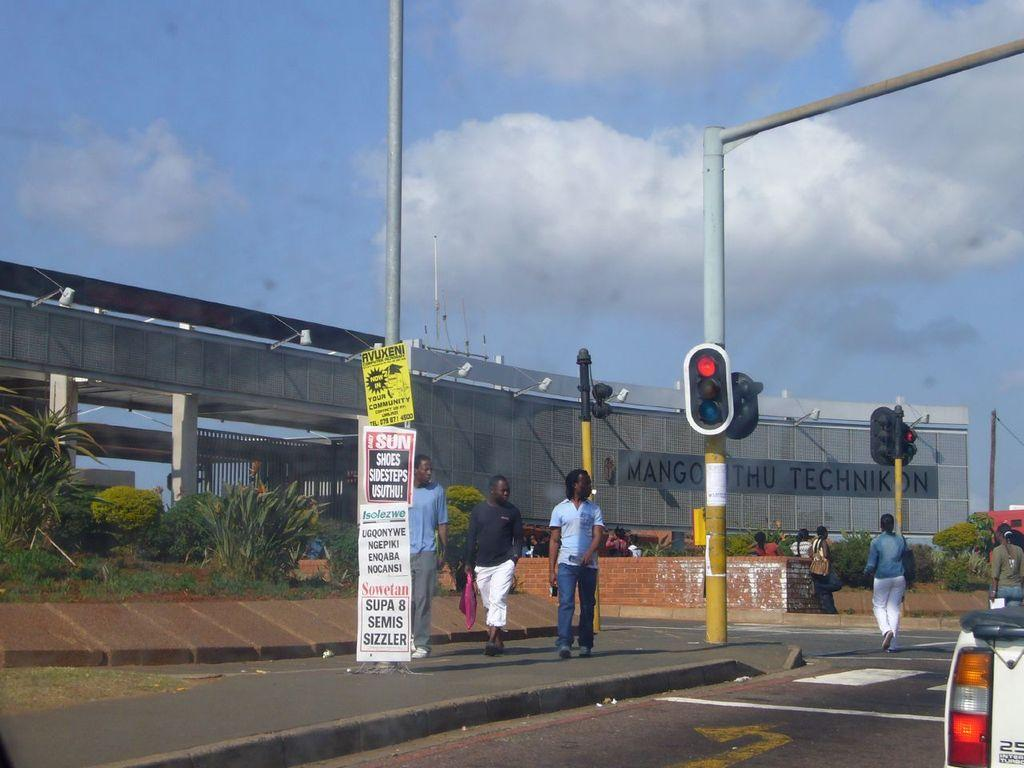<image>
Render a clear and concise summary of the photo. A myriad of signs sit near a stoplight that advertise Super 8 Semis. 